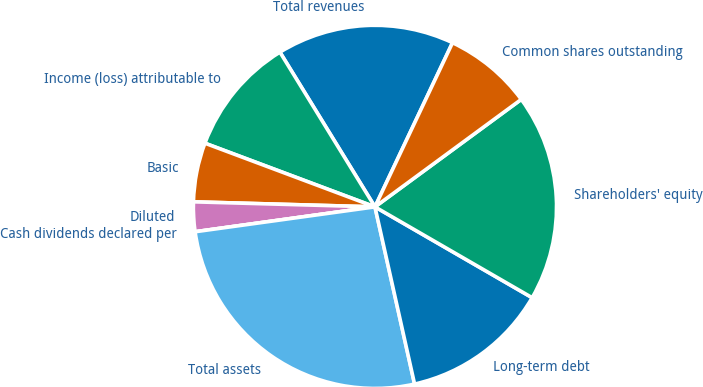Convert chart to OTSL. <chart><loc_0><loc_0><loc_500><loc_500><pie_chart><fcel>Total revenues<fcel>Income (loss) attributable to<fcel>Basic<fcel>Diluted<fcel>Cash dividends declared per<fcel>Total assets<fcel>Long-term debt<fcel>Shareholders' equity<fcel>Common shares outstanding<nl><fcel>15.79%<fcel>10.53%<fcel>5.26%<fcel>2.63%<fcel>0.0%<fcel>26.31%<fcel>13.16%<fcel>18.42%<fcel>7.89%<nl></chart> 